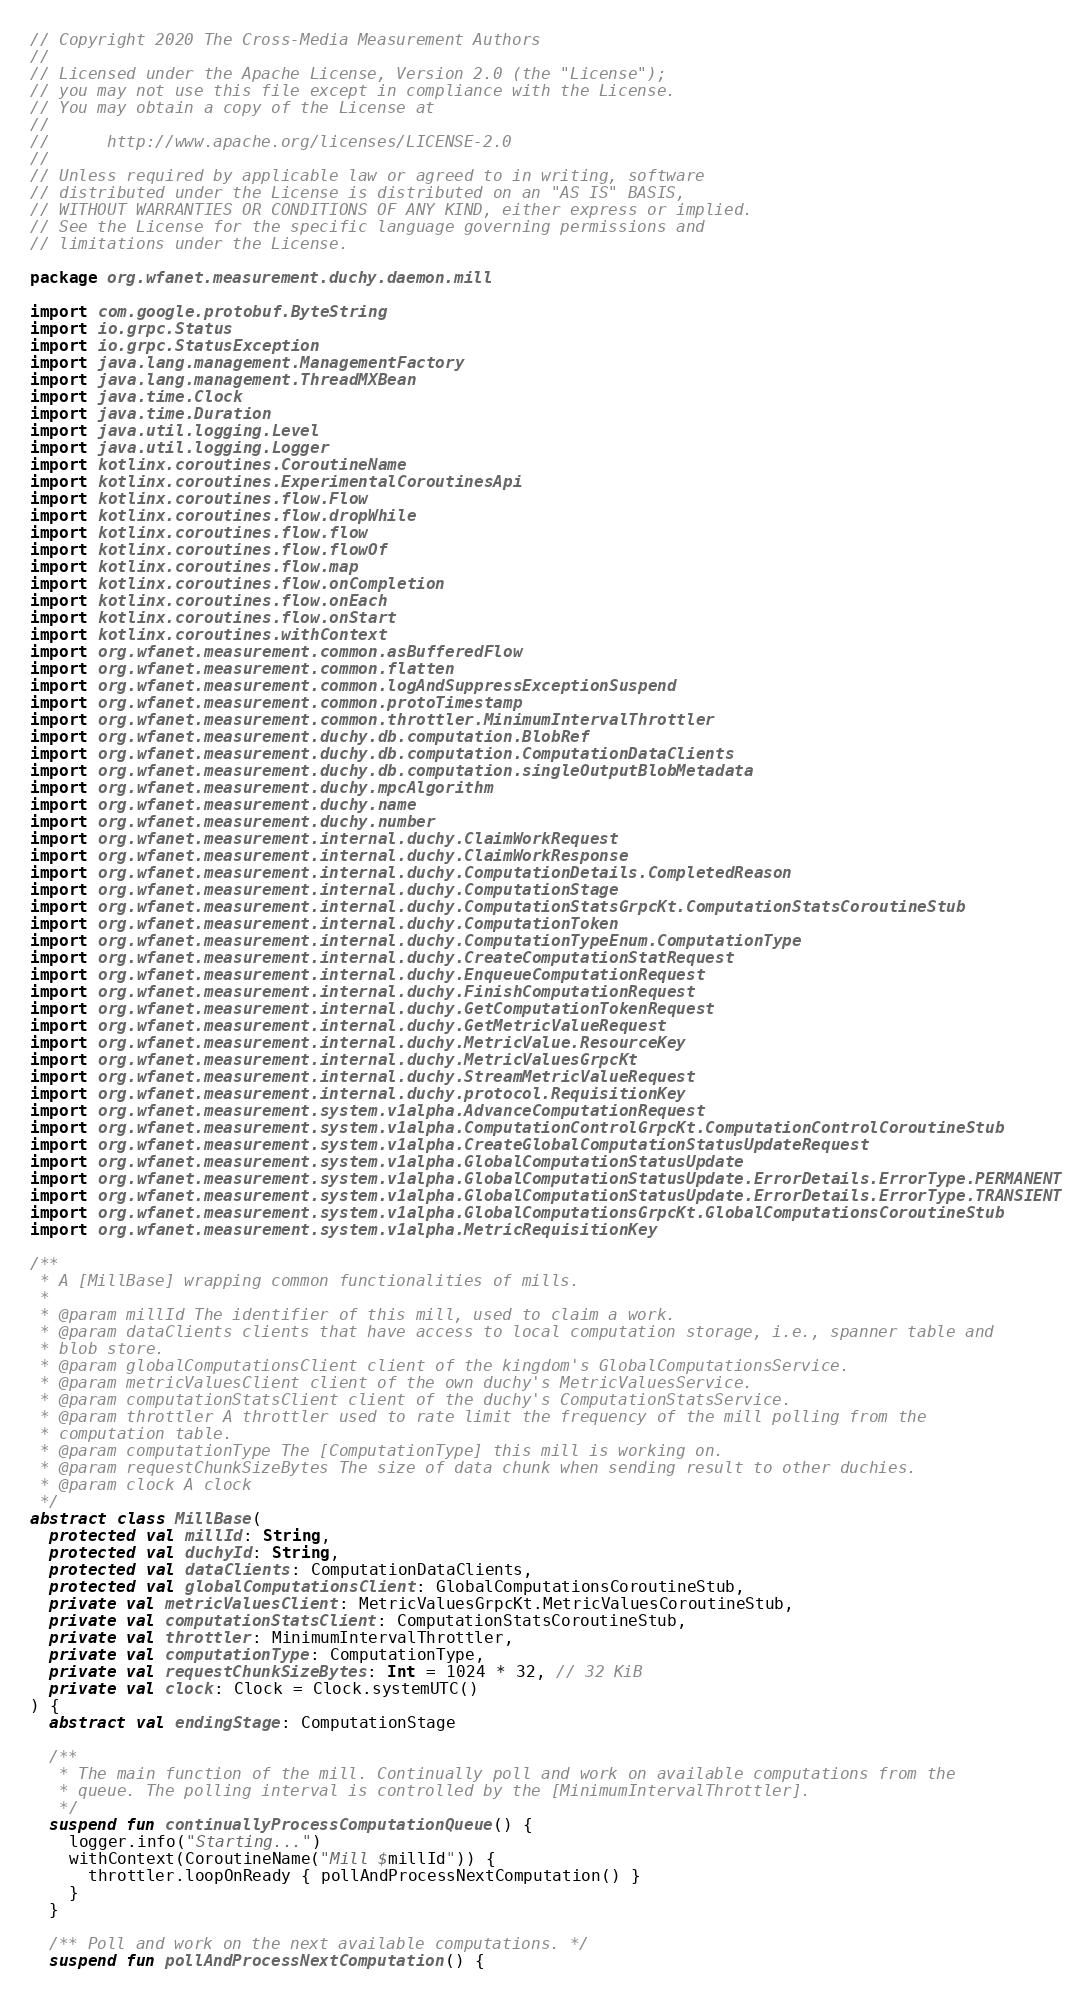Convert code to text. <code><loc_0><loc_0><loc_500><loc_500><_Kotlin_>// Copyright 2020 The Cross-Media Measurement Authors
//
// Licensed under the Apache License, Version 2.0 (the "License");
// you may not use this file except in compliance with the License.
// You may obtain a copy of the License at
//
//      http://www.apache.org/licenses/LICENSE-2.0
//
// Unless required by applicable law or agreed to in writing, software
// distributed under the License is distributed on an "AS IS" BASIS,
// WITHOUT WARRANTIES OR CONDITIONS OF ANY KIND, either express or implied.
// See the License for the specific language governing permissions and
// limitations under the License.

package org.wfanet.measurement.duchy.daemon.mill

import com.google.protobuf.ByteString
import io.grpc.Status
import io.grpc.StatusException
import java.lang.management.ManagementFactory
import java.lang.management.ThreadMXBean
import java.time.Clock
import java.time.Duration
import java.util.logging.Level
import java.util.logging.Logger
import kotlinx.coroutines.CoroutineName
import kotlinx.coroutines.ExperimentalCoroutinesApi
import kotlinx.coroutines.flow.Flow
import kotlinx.coroutines.flow.dropWhile
import kotlinx.coroutines.flow.flow
import kotlinx.coroutines.flow.flowOf
import kotlinx.coroutines.flow.map
import kotlinx.coroutines.flow.onCompletion
import kotlinx.coroutines.flow.onEach
import kotlinx.coroutines.flow.onStart
import kotlinx.coroutines.withContext
import org.wfanet.measurement.common.asBufferedFlow
import org.wfanet.measurement.common.flatten
import org.wfanet.measurement.common.logAndSuppressExceptionSuspend
import org.wfanet.measurement.common.protoTimestamp
import org.wfanet.measurement.common.throttler.MinimumIntervalThrottler
import org.wfanet.measurement.duchy.db.computation.BlobRef
import org.wfanet.measurement.duchy.db.computation.ComputationDataClients
import org.wfanet.measurement.duchy.db.computation.singleOutputBlobMetadata
import org.wfanet.measurement.duchy.mpcAlgorithm
import org.wfanet.measurement.duchy.name
import org.wfanet.measurement.duchy.number
import org.wfanet.measurement.internal.duchy.ClaimWorkRequest
import org.wfanet.measurement.internal.duchy.ClaimWorkResponse
import org.wfanet.measurement.internal.duchy.ComputationDetails.CompletedReason
import org.wfanet.measurement.internal.duchy.ComputationStage
import org.wfanet.measurement.internal.duchy.ComputationStatsGrpcKt.ComputationStatsCoroutineStub
import org.wfanet.measurement.internal.duchy.ComputationToken
import org.wfanet.measurement.internal.duchy.ComputationTypeEnum.ComputationType
import org.wfanet.measurement.internal.duchy.CreateComputationStatRequest
import org.wfanet.measurement.internal.duchy.EnqueueComputationRequest
import org.wfanet.measurement.internal.duchy.FinishComputationRequest
import org.wfanet.measurement.internal.duchy.GetComputationTokenRequest
import org.wfanet.measurement.internal.duchy.GetMetricValueRequest
import org.wfanet.measurement.internal.duchy.MetricValue.ResourceKey
import org.wfanet.measurement.internal.duchy.MetricValuesGrpcKt
import org.wfanet.measurement.internal.duchy.StreamMetricValueRequest
import org.wfanet.measurement.internal.duchy.protocol.RequisitionKey
import org.wfanet.measurement.system.v1alpha.AdvanceComputationRequest
import org.wfanet.measurement.system.v1alpha.ComputationControlGrpcKt.ComputationControlCoroutineStub
import org.wfanet.measurement.system.v1alpha.CreateGlobalComputationStatusUpdateRequest
import org.wfanet.measurement.system.v1alpha.GlobalComputationStatusUpdate
import org.wfanet.measurement.system.v1alpha.GlobalComputationStatusUpdate.ErrorDetails.ErrorType.PERMANENT
import org.wfanet.measurement.system.v1alpha.GlobalComputationStatusUpdate.ErrorDetails.ErrorType.TRANSIENT
import org.wfanet.measurement.system.v1alpha.GlobalComputationsGrpcKt.GlobalComputationsCoroutineStub
import org.wfanet.measurement.system.v1alpha.MetricRequisitionKey

/**
 * A [MillBase] wrapping common functionalities of mills.
 *
 * @param millId The identifier of this mill, used to claim a work.
 * @param dataClients clients that have access to local computation storage, i.e., spanner table and
 * blob store.
 * @param globalComputationsClient client of the kingdom's GlobalComputationsService.
 * @param metricValuesClient client of the own duchy's MetricValuesService.
 * @param computationStatsClient client of the duchy's ComputationStatsService.
 * @param throttler A throttler used to rate limit the frequency of the mill polling from the
 * computation table.
 * @param computationType The [ComputationType] this mill is working on.
 * @param requestChunkSizeBytes The size of data chunk when sending result to other duchies.
 * @param clock A clock
 */
abstract class MillBase(
  protected val millId: String,
  protected val duchyId: String,
  protected val dataClients: ComputationDataClients,
  protected val globalComputationsClient: GlobalComputationsCoroutineStub,
  private val metricValuesClient: MetricValuesGrpcKt.MetricValuesCoroutineStub,
  private val computationStatsClient: ComputationStatsCoroutineStub,
  private val throttler: MinimumIntervalThrottler,
  private val computationType: ComputationType,
  private val requestChunkSizeBytes: Int = 1024 * 32, // 32 KiB
  private val clock: Clock = Clock.systemUTC()
) {
  abstract val endingStage: ComputationStage

  /**
   * The main function of the mill. Continually poll and work on available computations from the
   * queue. The polling interval is controlled by the [MinimumIntervalThrottler].
   */
  suspend fun continuallyProcessComputationQueue() {
    logger.info("Starting...")
    withContext(CoroutineName("Mill $millId")) {
      throttler.loopOnReady { pollAndProcessNextComputation() }
    }
  }

  /** Poll and work on the next available computations. */
  suspend fun pollAndProcessNextComputation() {</code> 